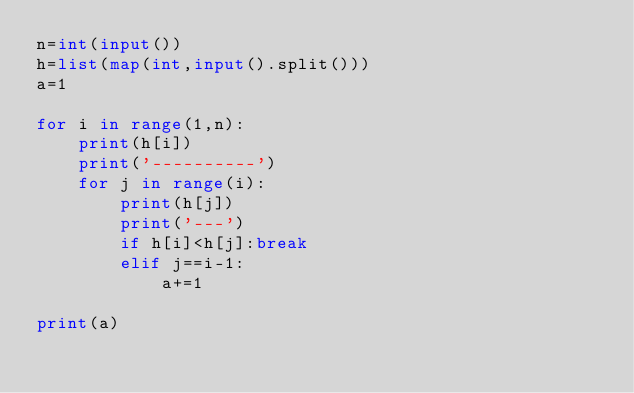<code> <loc_0><loc_0><loc_500><loc_500><_Python_>n=int(input())
h=list(map(int,input().split()))
a=1

for i in range(1,n):
    print(h[i])
    print('----------')
    for j in range(i):
        print(h[j])
        print('---')
        if h[i]<h[j]:break
        elif j==i-1:
            a+=1

print(a)</code> 